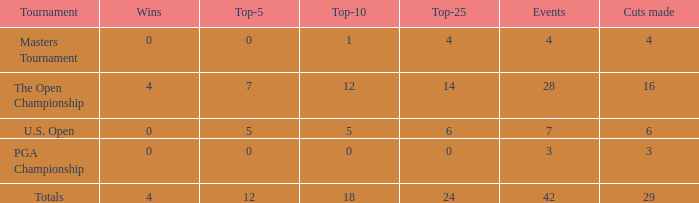What is the lowest for top-25 with events smaller than 42 in a U.S. Open with a top-10 smaller than 5? None. 